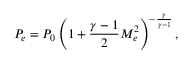Convert formula to latex. <formula><loc_0><loc_0><loc_500><loc_500>P _ { e } = P _ { 0 } \left ( 1 + \frac { \gamma - 1 } { 2 } M _ { e } ^ { 2 } \right ) ^ { - \frac { \gamma } { \gamma - 1 } } ,</formula> 